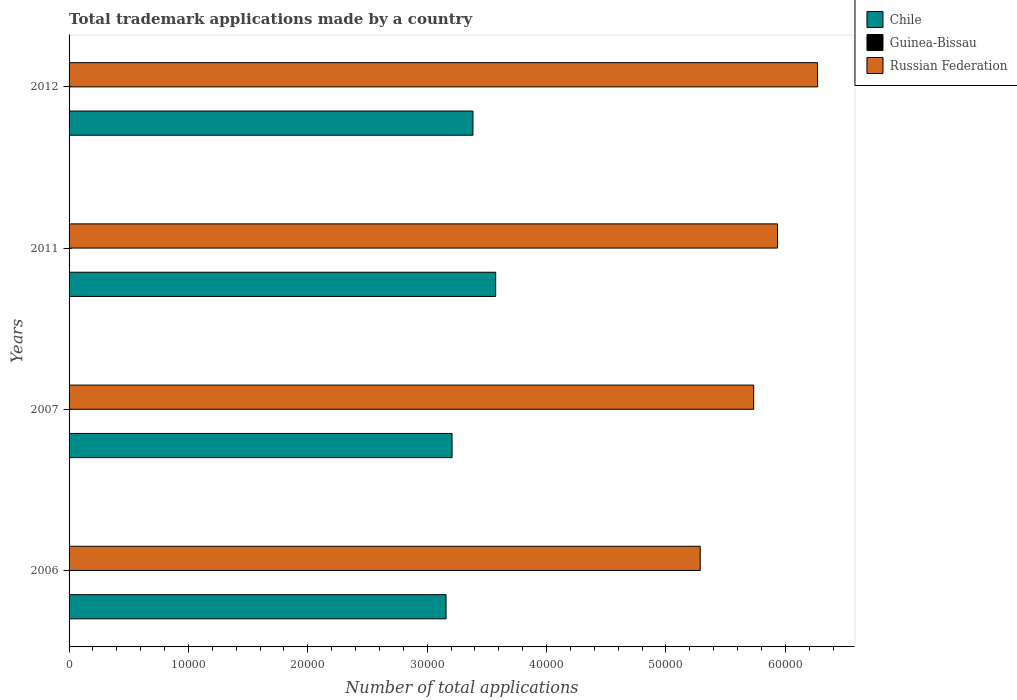Are the number of bars per tick equal to the number of legend labels?
Provide a short and direct response. Yes. Are the number of bars on each tick of the Y-axis equal?
Ensure brevity in your answer.  Yes. How many bars are there on the 4th tick from the top?
Keep it short and to the point. 3. In how many cases, is the number of bars for a given year not equal to the number of legend labels?
Ensure brevity in your answer.  0. Across all years, what is the maximum number of applications made by in Russian Federation?
Make the answer very short. 6.27e+04. Across all years, what is the minimum number of applications made by in Chile?
Offer a very short reply. 3.16e+04. In which year was the number of applications made by in Guinea-Bissau minimum?
Offer a terse response. 2006. What is the total number of applications made by in Russian Federation in the graph?
Your response must be concise. 2.32e+05. What is the difference between the number of applications made by in Chile in 2006 and that in 2007?
Your response must be concise. -504. What is the difference between the number of applications made by in Russian Federation in 2011 and the number of applications made by in Guinea-Bissau in 2007?
Provide a succinct answer. 5.93e+04. What is the average number of applications made by in Chile per year?
Your answer should be very brief. 3.33e+04. In the year 2012, what is the difference between the number of applications made by in Russian Federation and number of applications made by in Guinea-Bissau?
Offer a terse response. 6.27e+04. In how many years, is the number of applications made by in Russian Federation greater than 62000 ?
Your response must be concise. 1. What is the ratio of the number of applications made by in Chile in 2006 to that in 2007?
Make the answer very short. 0.98. Is the number of applications made by in Chile in 2011 less than that in 2012?
Offer a very short reply. No. Is the difference between the number of applications made by in Russian Federation in 2006 and 2012 greater than the difference between the number of applications made by in Guinea-Bissau in 2006 and 2012?
Offer a very short reply. No. What is the difference between the highest and the second highest number of applications made by in Chile?
Provide a short and direct response. 1902. What is the difference between the highest and the lowest number of applications made by in Chile?
Provide a short and direct response. 4156. In how many years, is the number of applications made by in Guinea-Bissau greater than the average number of applications made by in Guinea-Bissau taken over all years?
Give a very brief answer. 2. What does the 1st bar from the top in 2006 represents?
Provide a short and direct response. Russian Federation. What does the 3rd bar from the bottom in 2011 represents?
Your response must be concise. Russian Federation. Are all the bars in the graph horizontal?
Your answer should be very brief. Yes. How many years are there in the graph?
Your answer should be compact. 4. How are the legend labels stacked?
Give a very brief answer. Vertical. What is the title of the graph?
Give a very brief answer. Total trademark applications made by a country. Does "Slovak Republic" appear as one of the legend labels in the graph?
Your answer should be compact. No. What is the label or title of the X-axis?
Ensure brevity in your answer.  Number of total applications. What is the label or title of the Y-axis?
Offer a terse response. Years. What is the Number of total applications in Chile in 2006?
Offer a very short reply. 3.16e+04. What is the Number of total applications in Guinea-Bissau in 2006?
Offer a very short reply. 5. What is the Number of total applications of Russian Federation in 2006?
Ensure brevity in your answer.  5.29e+04. What is the Number of total applications in Chile in 2007?
Ensure brevity in your answer.  3.21e+04. What is the Number of total applications in Guinea-Bissau in 2007?
Ensure brevity in your answer.  6. What is the Number of total applications in Russian Federation in 2007?
Offer a terse response. 5.73e+04. What is the Number of total applications in Chile in 2011?
Provide a succinct answer. 3.57e+04. What is the Number of total applications of Russian Federation in 2011?
Your response must be concise. 5.93e+04. What is the Number of total applications of Chile in 2012?
Offer a terse response. 3.38e+04. What is the Number of total applications in Guinea-Bissau in 2012?
Ensure brevity in your answer.  12. What is the Number of total applications in Russian Federation in 2012?
Make the answer very short. 6.27e+04. Across all years, what is the maximum Number of total applications in Chile?
Your response must be concise. 3.57e+04. Across all years, what is the maximum Number of total applications in Guinea-Bissau?
Your answer should be very brief. 12. Across all years, what is the maximum Number of total applications in Russian Federation?
Keep it short and to the point. 6.27e+04. Across all years, what is the minimum Number of total applications of Chile?
Ensure brevity in your answer.  3.16e+04. Across all years, what is the minimum Number of total applications in Russian Federation?
Make the answer very short. 5.29e+04. What is the total Number of total applications in Chile in the graph?
Keep it short and to the point. 1.33e+05. What is the total Number of total applications in Guinea-Bissau in the graph?
Provide a short and direct response. 34. What is the total Number of total applications of Russian Federation in the graph?
Offer a terse response. 2.32e+05. What is the difference between the Number of total applications of Chile in 2006 and that in 2007?
Offer a very short reply. -504. What is the difference between the Number of total applications in Russian Federation in 2006 and that in 2007?
Give a very brief answer. -4479. What is the difference between the Number of total applications of Chile in 2006 and that in 2011?
Your answer should be very brief. -4156. What is the difference between the Number of total applications of Russian Federation in 2006 and that in 2011?
Make the answer very short. -6474. What is the difference between the Number of total applications in Chile in 2006 and that in 2012?
Provide a succinct answer. -2254. What is the difference between the Number of total applications of Russian Federation in 2006 and that in 2012?
Offer a terse response. -9827. What is the difference between the Number of total applications of Chile in 2007 and that in 2011?
Give a very brief answer. -3652. What is the difference between the Number of total applications in Guinea-Bissau in 2007 and that in 2011?
Offer a terse response. -5. What is the difference between the Number of total applications in Russian Federation in 2007 and that in 2011?
Offer a terse response. -1995. What is the difference between the Number of total applications in Chile in 2007 and that in 2012?
Ensure brevity in your answer.  -1750. What is the difference between the Number of total applications of Guinea-Bissau in 2007 and that in 2012?
Offer a very short reply. -6. What is the difference between the Number of total applications in Russian Federation in 2007 and that in 2012?
Give a very brief answer. -5348. What is the difference between the Number of total applications of Chile in 2011 and that in 2012?
Make the answer very short. 1902. What is the difference between the Number of total applications of Russian Federation in 2011 and that in 2012?
Ensure brevity in your answer.  -3353. What is the difference between the Number of total applications in Chile in 2006 and the Number of total applications in Guinea-Bissau in 2007?
Ensure brevity in your answer.  3.16e+04. What is the difference between the Number of total applications in Chile in 2006 and the Number of total applications in Russian Federation in 2007?
Your response must be concise. -2.58e+04. What is the difference between the Number of total applications of Guinea-Bissau in 2006 and the Number of total applications of Russian Federation in 2007?
Provide a succinct answer. -5.73e+04. What is the difference between the Number of total applications in Chile in 2006 and the Number of total applications in Guinea-Bissau in 2011?
Your answer should be very brief. 3.16e+04. What is the difference between the Number of total applications of Chile in 2006 and the Number of total applications of Russian Federation in 2011?
Keep it short and to the point. -2.78e+04. What is the difference between the Number of total applications of Guinea-Bissau in 2006 and the Number of total applications of Russian Federation in 2011?
Your answer should be compact. -5.93e+04. What is the difference between the Number of total applications in Chile in 2006 and the Number of total applications in Guinea-Bissau in 2012?
Your answer should be compact. 3.16e+04. What is the difference between the Number of total applications in Chile in 2006 and the Number of total applications in Russian Federation in 2012?
Your answer should be compact. -3.11e+04. What is the difference between the Number of total applications in Guinea-Bissau in 2006 and the Number of total applications in Russian Federation in 2012?
Keep it short and to the point. -6.27e+04. What is the difference between the Number of total applications in Chile in 2007 and the Number of total applications in Guinea-Bissau in 2011?
Your answer should be very brief. 3.21e+04. What is the difference between the Number of total applications of Chile in 2007 and the Number of total applications of Russian Federation in 2011?
Provide a succinct answer. -2.73e+04. What is the difference between the Number of total applications of Guinea-Bissau in 2007 and the Number of total applications of Russian Federation in 2011?
Provide a short and direct response. -5.93e+04. What is the difference between the Number of total applications of Chile in 2007 and the Number of total applications of Guinea-Bissau in 2012?
Your response must be concise. 3.21e+04. What is the difference between the Number of total applications of Chile in 2007 and the Number of total applications of Russian Federation in 2012?
Your answer should be compact. -3.06e+04. What is the difference between the Number of total applications of Guinea-Bissau in 2007 and the Number of total applications of Russian Federation in 2012?
Give a very brief answer. -6.27e+04. What is the difference between the Number of total applications of Chile in 2011 and the Number of total applications of Guinea-Bissau in 2012?
Your answer should be compact. 3.57e+04. What is the difference between the Number of total applications in Chile in 2011 and the Number of total applications in Russian Federation in 2012?
Offer a very short reply. -2.70e+04. What is the difference between the Number of total applications of Guinea-Bissau in 2011 and the Number of total applications of Russian Federation in 2012?
Your answer should be very brief. -6.27e+04. What is the average Number of total applications in Chile per year?
Make the answer very short. 3.33e+04. What is the average Number of total applications in Guinea-Bissau per year?
Offer a terse response. 8.5. What is the average Number of total applications in Russian Federation per year?
Keep it short and to the point. 5.81e+04. In the year 2006, what is the difference between the Number of total applications in Chile and Number of total applications in Guinea-Bissau?
Your answer should be compact. 3.16e+04. In the year 2006, what is the difference between the Number of total applications in Chile and Number of total applications in Russian Federation?
Make the answer very short. -2.13e+04. In the year 2006, what is the difference between the Number of total applications in Guinea-Bissau and Number of total applications in Russian Federation?
Your answer should be very brief. -5.29e+04. In the year 2007, what is the difference between the Number of total applications in Chile and Number of total applications in Guinea-Bissau?
Your answer should be very brief. 3.21e+04. In the year 2007, what is the difference between the Number of total applications in Chile and Number of total applications in Russian Federation?
Offer a terse response. -2.53e+04. In the year 2007, what is the difference between the Number of total applications of Guinea-Bissau and Number of total applications of Russian Federation?
Keep it short and to the point. -5.73e+04. In the year 2011, what is the difference between the Number of total applications in Chile and Number of total applications in Guinea-Bissau?
Offer a terse response. 3.57e+04. In the year 2011, what is the difference between the Number of total applications of Chile and Number of total applications of Russian Federation?
Give a very brief answer. -2.36e+04. In the year 2011, what is the difference between the Number of total applications of Guinea-Bissau and Number of total applications of Russian Federation?
Keep it short and to the point. -5.93e+04. In the year 2012, what is the difference between the Number of total applications of Chile and Number of total applications of Guinea-Bissau?
Ensure brevity in your answer.  3.38e+04. In the year 2012, what is the difference between the Number of total applications of Chile and Number of total applications of Russian Federation?
Make the answer very short. -2.89e+04. In the year 2012, what is the difference between the Number of total applications in Guinea-Bissau and Number of total applications in Russian Federation?
Offer a terse response. -6.27e+04. What is the ratio of the Number of total applications of Chile in 2006 to that in 2007?
Your answer should be compact. 0.98. What is the ratio of the Number of total applications in Guinea-Bissau in 2006 to that in 2007?
Ensure brevity in your answer.  0.83. What is the ratio of the Number of total applications of Russian Federation in 2006 to that in 2007?
Provide a short and direct response. 0.92. What is the ratio of the Number of total applications of Chile in 2006 to that in 2011?
Your answer should be very brief. 0.88. What is the ratio of the Number of total applications of Guinea-Bissau in 2006 to that in 2011?
Ensure brevity in your answer.  0.45. What is the ratio of the Number of total applications in Russian Federation in 2006 to that in 2011?
Offer a terse response. 0.89. What is the ratio of the Number of total applications of Chile in 2006 to that in 2012?
Your answer should be compact. 0.93. What is the ratio of the Number of total applications in Guinea-Bissau in 2006 to that in 2012?
Make the answer very short. 0.42. What is the ratio of the Number of total applications in Russian Federation in 2006 to that in 2012?
Give a very brief answer. 0.84. What is the ratio of the Number of total applications in Chile in 2007 to that in 2011?
Offer a very short reply. 0.9. What is the ratio of the Number of total applications in Guinea-Bissau in 2007 to that in 2011?
Your answer should be compact. 0.55. What is the ratio of the Number of total applications of Russian Federation in 2007 to that in 2011?
Ensure brevity in your answer.  0.97. What is the ratio of the Number of total applications of Chile in 2007 to that in 2012?
Ensure brevity in your answer.  0.95. What is the ratio of the Number of total applications in Guinea-Bissau in 2007 to that in 2012?
Offer a terse response. 0.5. What is the ratio of the Number of total applications of Russian Federation in 2007 to that in 2012?
Provide a short and direct response. 0.91. What is the ratio of the Number of total applications in Chile in 2011 to that in 2012?
Ensure brevity in your answer.  1.06. What is the ratio of the Number of total applications in Guinea-Bissau in 2011 to that in 2012?
Make the answer very short. 0.92. What is the ratio of the Number of total applications in Russian Federation in 2011 to that in 2012?
Your answer should be very brief. 0.95. What is the difference between the highest and the second highest Number of total applications of Chile?
Offer a very short reply. 1902. What is the difference between the highest and the second highest Number of total applications in Russian Federation?
Offer a very short reply. 3353. What is the difference between the highest and the lowest Number of total applications in Chile?
Make the answer very short. 4156. What is the difference between the highest and the lowest Number of total applications of Guinea-Bissau?
Give a very brief answer. 7. What is the difference between the highest and the lowest Number of total applications of Russian Federation?
Offer a terse response. 9827. 